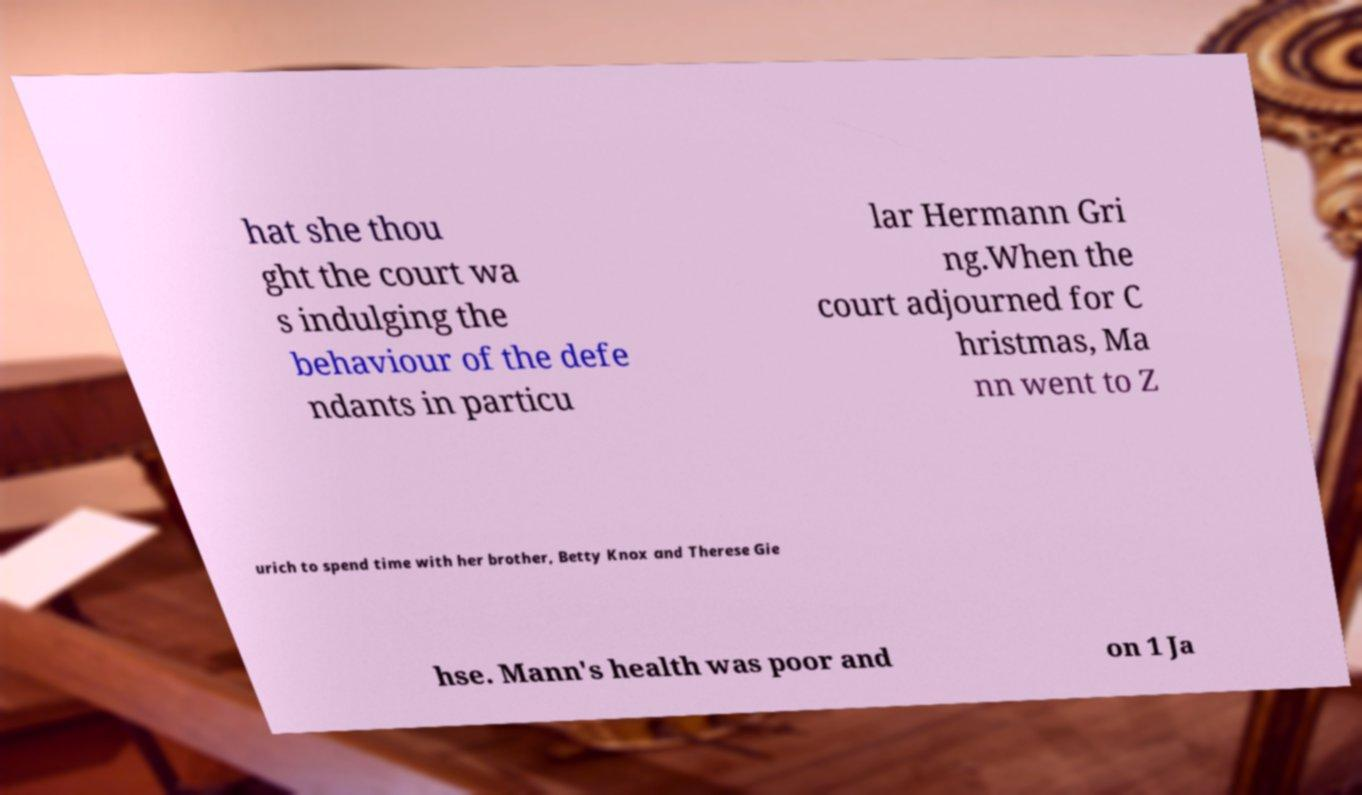Please identify and transcribe the text found in this image. hat she thou ght the court wa s indulging the behaviour of the defe ndants in particu lar Hermann Gri ng.When the court adjourned for C hristmas, Ma nn went to Z urich to spend time with her brother, Betty Knox and Therese Gie hse. Mann's health was poor and on 1 Ja 